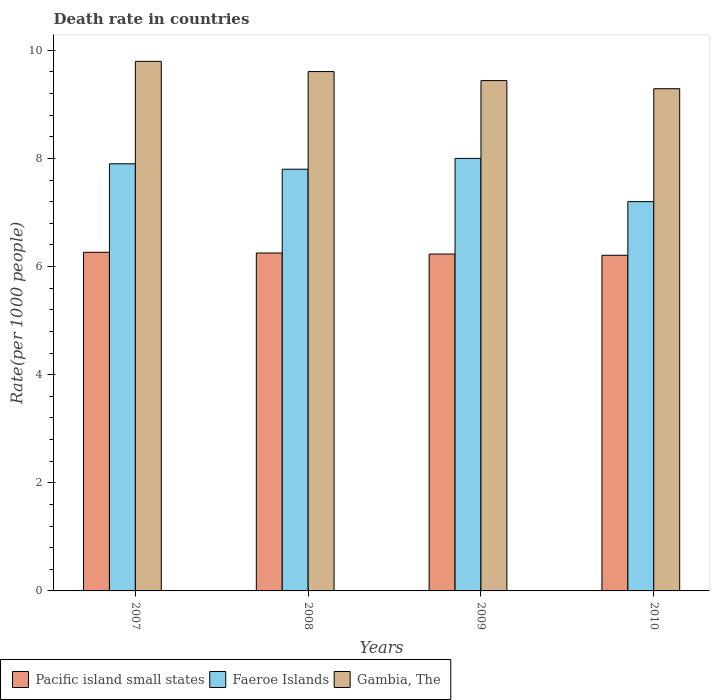How many groups of bars are there?
Ensure brevity in your answer.  4. Are the number of bars per tick equal to the number of legend labels?
Provide a succinct answer. Yes. Are the number of bars on each tick of the X-axis equal?
Your answer should be compact. Yes. What is the death rate in Pacific island small states in 2007?
Offer a terse response. 6.26. Across all years, what is the minimum death rate in Gambia, The?
Your response must be concise. 9.29. In which year was the death rate in Faeroe Islands maximum?
Keep it short and to the point. 2009. In which year was the death rate in Faeroe Islands minimum?
Offer a terse response. 2010. What is the total death rate in Pacific island small states in the graph?
Your response must be concise. 24.95. What is the difference between the death rate in Faeroe Islands in 2008 and that in 2009?
Ensure brevity in your answer.  -0.2. What is the difference between the death rate in Pacific island small states in 2010 and the death rate in Gambia, The in 2009?
Give a very brief answer. -3.23. What is the average death rate in Faeroe Islands per year?
Make the answer very short. 7.72. In the year 2007, what is the difference between the death rate in Gambia, The and death rate in Pacific island small states?
Give a very brief answer. 3.53. What is the ratio of the death rate in Gambia, The in 2007 to that in 2010?
Your answer should be compact. 1.05. Is the death rate in Gambia, The in 2007 less than that in 2009?
Make the answer very short. No. Is the difference between the death rate in Gambia, The in 2008 and 2010 greater than the difference between the death rate in Pacific island small states in 2008 and 2010?
Provide a succinct answer. Yes. What is the difference between the highest and the second highest death rate in Gambia, The?
Make the answer very short. 0.19. What is the difference between the highest and the lowest death rate in Faeroe Islands?
Your response must be concise. 0.8. What does the 2nd bar from the left in 2010 represents?
Provide a short and direct response. Faeroe Islands. What does the 3rd bar from the right in 2009 represents?
Provide a short and direct response. Pacific island small states. Is it the case that in every year, the sum of the death rate in Pacific island small states and death rate in Faeroe Islands is greater than the death rate in Gambia, The?
Keep it short and to the point. Yes. How many bars are there?
Give a very brief answer. 12. Are all the bars in the graph horizontal?
Your answer should be very brief. No. How many years are there in the graph?
Make the answer very short. 4. Are the values on the major ticks of Y-axis written in scientific E-notation?
Ensure brevity in your answer.  No. What is the title of the graph?
Your answer should be very brief. Death rate in countries. What is the label or title of the X-axis?
Provide a succinct answer. Years. What is the label or title of the Y-axis?
Provide a succinct answer. Rate(per 1000 people). What is the Rate(per 1000 people) in Pacific island small states in 2007?
Make the answer very short. 6.26. What is the Rate(per 1000 people) of Gambia, The in 2007?
Your answer should be very brief. 9.79. What is the Rate(per 1000 people) in Pacific island small states in 2008?
Make the answer very short. 6.25. What is the Rate(per 1000 people) of Faeroe Islands in 2008?
Your answer should be compact. 7.8. What is the Rate(per 1000 people) in Gambia, The in 2008?
Provide a short and direct response. 9.61. What is the Rate(per 1000 people) of Pacific island small states in 2009?
Make the answer very short. 6.23. What is the Rate(per 1000 people) of Faeroe Islands in 2009?
Provide a short and direct response. 8. What is the Rate(per 1000 people) in Gambia, The in 2009?
Make the answer very short. 9.44. What is the Rate(per 1000 people) of Pacific island small states in 2010?
Provide a succinct answer. 6.21. What is the Rate(per 1000 people) in Gambia, The in 2010?
Make the answer very short. 9.29. Across all years, what is the maximum Rate(per 1000 people) of Pacific island small states?
Your answer should be compact. 6.26. Across all years, what is the maximum Rate(per 1000 people) of Faeroe Islands?
Your answer should be very brief. 8. Across all years, what is the maximum Rate(per 1000 people) of Gambia, The?
Provide a short and direct response. 9.79. Across all years, what is the minimum Rate(per 1000 people) of Pacific island small states?
Ensure brevity in your answer.  6.21. Across all years, what is the minimum Rate(per 1000 people) in Gambia, The?
Ensure brevity in your answer.  9.29. What is the total Rate(per 1000 people) in Pacific island small states in the graph?
Offer a terse response. 24.95. What is the total Rate(per 1000 people) in Faeroe Islands in the graph?
Your answer should be very brief. 30.9. What is the total Rate(per 1000 people) of Gambia, The in the graph?
Provide a short and direct response. 38.13. What is the difference between the Rate(per 1000 people) of Pacific island small states in 2007 and that in 2008?
Make the answer very short. 0.01. What is the difference between the Rate(per 1000 people) in Gambia, The in 2007 and that in 2008?
Ensure brevity in your answer.  0.19. What is the difference between the Rate(per 1000 people) of Pacific island small states in 2007 and that in 2009?
Your answer should be very brief. 0.03. What is the difference between the Rate(per 1000 people) in Faeroe Islands in 2007 and that in 2009?
Offer a terse response. -0.1. What is the difference between the Rate(per 1000 people) of Gambia, The in 2007 and that in 2009?
Your answer should be very brief. 0.36. What is the difference between the Rate(per 1000 people) of Pacific island small states in 2007 and that in 2010?
Your answer should be very brief. 0.06. What is the difference between the Rate(per 1000 people) of Gambia, The in 2007 and that in 2010?
Your response must be concise. 0.51. What is the difference between the Rate(per 1000 people) in Pacific island small states in 2008 and that in 2009?
Provide a short and direct response. 0.02. What is the difference between the Rate(per 1000 people) of Gambia, The in 2008 and that in 2009?
Provide a succinct answer. 0.17. What is the difference between the Rate(per 1000 people) of Pacific island small states in 2008 and that in 2010?
Your answer should be compact. 0.04. What is the difference between the Rate(per 1000 people) in Gambia, The in 2008 and that in 2010?
Your response must be concise. 0.32. What is the difference between the Rate(per 1000 people) in Pacific island small states in 2009 and that in 2010?
Provide a succinct answer. 0.02. What is the difference between the Rate(per 1000 people) of Pacific island small states in 2007 and the Rate(per 1000 people) of Faeroe Islands in 2008?
Provide a short and direct response. -1.54. What is the difference between the Rate(per 1000 people) of Pacific island small states in 2007 and the Rate(per 1000 people) of Gambia, The in 2008?
Provide a short and direct response. -3.34. What is the difference between the Rate(per 1000 people) in Faeroe Islands in 2007 and the Rate(per 1000 people) in Gambia, The in 2008?
Offer a very short reply. -1.71. What is the difference between the Rate(per 1000 people) of Pacific island small states in 2007 and the Rate(per 1000 people) of Faeroe Islands in 2009?
Your answer should be compact. -1.74. What is the difference between the Rate(per 1000 people) in Pacific island small states in 2007 and the Rate(per 1000 people) in Gambia, The in 2009?
Offer a very short reply. -3.18. What is the difference between the Rate(per 1000 people) in Faeroe Islands in 2007 and the Rate(per 1000 people) in Gambia, The in 2009?
Provide a short and direct response. -1.54. What is the difference between the Rate(per 1000 people) in Pacific island small states in 2007 and the Rate(per 1000 people) in Faeroe Islands in 2010?
Ensure brevity in your answer.  -0.94. What is the difference between the Rate(per 1000 people) in Pacific island small states in 2007 and the Rate(per 1000 people) in Gambia, The in 2010?
Offer a very short reply. -3.03. What is the difference between the Rate(per 1000 people) of Faeroe Islands in 2007 and the Rate(per 1000 people) of Gambia, The in 2010?
Keep it short and to the point. -1.39. What is the difference between the Rate(per 1000 people) of Pacific island small states in 2008 and the Rate(per 1000 people) of Faeroe Islands in 2009?
Provide a succinct answer. -1.75. What is the difference between the Rate(per 1000 people) of Pacific island small states in 2008 and the Rate(per 1000 people) of Gambia, The in 2009?
Your response must be concise. -3.19. What is the difference between the Rate(per 1000 people) in Faeroe Islands in 2008 and the Rate(per 1000 people) in Gambia, The in 2009?
Give a very brief answer. -1.64. What is the difference between the Rate(per 1000 people) of Pacific island small states in 2008 and the Rate(per 1000 people) of Faeroe Islands in 2010?
Offer a terse response. -0.95. What is the difference between the Rate(per 1000 people) of Pacific island small states in 2008 and the Rate(per 1000 people) of Gambia, The in 2010?
Provide a short and direct response. -3.04. What is the difference between the Rate(per 1000 people) in Faeroe Islands in 2008 and the Rate(per 1000 people) in Gambia, The in 2010?
Your response must be concise. -1.49. What is the difference between the Rate(per 1000 people) of Pacific island small states in 2009 and the Rate(per 1000 people) of Faeroe Islands in 2010?
Offer a terse response. -0.97. What is the difference between the Rate(per 1000 people) in Pacific island small states in 2009 and the Rate(per 1000 people) in Gambia, The in 2010?
Ensure brevity in your answer.  -3.06. What is the difference between the Rate(per 1000 people) in Faeroe Islands in 2009 and the Rate(per 1000 people) in Gambia, The in 2010?
Give a very brief answer. -1.29. What is the average Rate(per 1000 people) of Pacific island small states per year?
Keep it short and to the point. 6.24. What is the average Rate(per 1000 people) of Faeroe Islands per year?
Offer a terse response. 7.72. What is the average Rate(per 1000 people) in Gambia, The per year?
Make the answer very short. 9.53. In the year 2007, what is the difference between the Rate(per 1000 people) in Pacific island small states and Rate(per 1000 people) in Faeroe Islands?
Your answer should be compact. -1.64. In the year 2007, what is the difference between the Rate(per 1000 people) of Pacific island small states and Rate(per 1000 people) of Gambia, The?
Offer a terse response. -3.53. In the year 2007, what is the difference between the Rate(per 1000 people) in Faeroe Islands and Rate(per 1000 people) in Gambia, The?
Make the answer very short. -1.9. In the year 2008, what is the difference between the Rate(per 1000 people) of Pacific island small states and Rate(per 1000 people) of Faeroe Islands?
Your answer should be very brief. -1.55. In the year 2008, what is the difference between the Rate(per 1000 people) of Pacific island small states and Rate(per 1000 people) of Gambia, The?
Ensure brevity in your answer.  -3.36. In the year 2008, what is the difference between the Rate(per 1000 people) of Faeroe Islands and Rate(per 1000 people) of Gambia, The?
Your answer should be compact. -1.81. In the year 2009, what is the difference between the Rate(per 1000 people) of Pacific island small states and Rate(per 1000 people) of Faeroe Islands?
Offer a terse response. -1.77. In the year 2009, what is the difference between the Rate(per 1000 people) of Pacific island small states and Rate(per 1000 people) of Gambia, The?
Your answer should be compact. -3.21. In the year 2009, what is the difference between the Rate(per 1000 people) in Faeroe Islands and Rate(per 1000 people) in Gambia, The?
Provide a succinct answer. -1.44. In the year 2010, what is the difference between the Rate(per 1000 people) of Pacific island small states and Rate(per 1000 people) of Faeroe Islands?
Offer a very short reply. -0.99. In the year 2010, what is the difference between the Rate(per 1000 people) of Pacific island small states and Rate(per 1000 people) of Gambia, The?
Your answer should be compact. -3.08. In the year 2010, what is the difference between the Rate(per 1000 people) of Faeroe Islands and Rate(per 1000 people) of Gambia, The?
Ensure brevity in your answer.  -2.09. What is the ratio of the Rate(per 1000 people) of Faeroe Islands in 2007 to that in 2008?
Offer a terse response. 1.01. What is the ratio of the Rate(per 1000 people) in Gambia, The in 2007 to that in 2008?
Your response must be concise. 1.02. What is the ratio of the Rate(per 1000 people) of Pacific island small states in 2007 to that in 2009?
Provide a succinct answer. 1.01. What is the ratio of the Rate(per 1000 people) of Faeroe Islands in 2007 to that in 2009?
Provide a short and direct response. 0.99. What is the ratio of the Rate(per 1000 people) of Gambia, The in 2007 to that in 2009?
Offer a terse response. 1.04. What is the ratio of the Rate(per 1000 people) in Pacific island small states in 2007 to that in 2010?
Offer a very short reply. 1.01. What is the ratio of the Rate(per 1000 people) of Faeroe Islands in 2007 to that in 2010?
Your answer should be compact. 1.1. What is the ratio of the Rate(per 1000 people) of Gambia, The in 2007 to that in 2010?
Offer a very short reply. 1.05. What is the ratio of the Rate(per 1000 people) in Gambia, The in 2008 to that in 2009?
Your answer should be compact. 1.02. What is the ratio of the Rate(per 1000 people) of Faeroe Islands in 2008 to that in 2010?
Give a very brief answer. 1.08. What is the ratio of the Rate(per 1000 people) of Gambia, The in 2008 to that in 2010?
Your answer should be compact. 1.03. What is the ratio of the Rate(per 1000 people) in Faeroe Islands in 2009 to that in 2010?
Give a very brief answer. 1.11. What is the ratio of the Rate(per 1000 people) in Gambia, The in 2009 to that in 2010?
Your response must be concise. 1.02. What is the difference between the highest and the second highest Rate(per 1000 people) in Pacific island small states?
Your answer should be compact. 0.01. What is the difference between the highest and the second highest Rate(per 1000 people) of Gambia, The?
Keep it short and to the point. 0.19. What is the difference between the highest and the lowest Rate(per 1000 people) in Pacific island small states?
Give a very brief answer. 0.06. What is the difference between the highest and the lowest Rate(per 1000 people) of Gambia, The?
Ensure brevity in your answer.  0.51. 